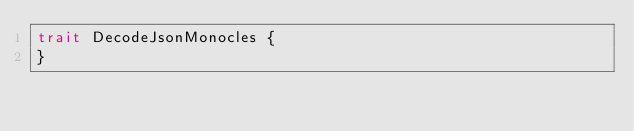Convert code to text. <code><loc_0><loc_0><loc_500><loc_500><_Scala_>trait DecodeJsonMonocles {
}
</code> 